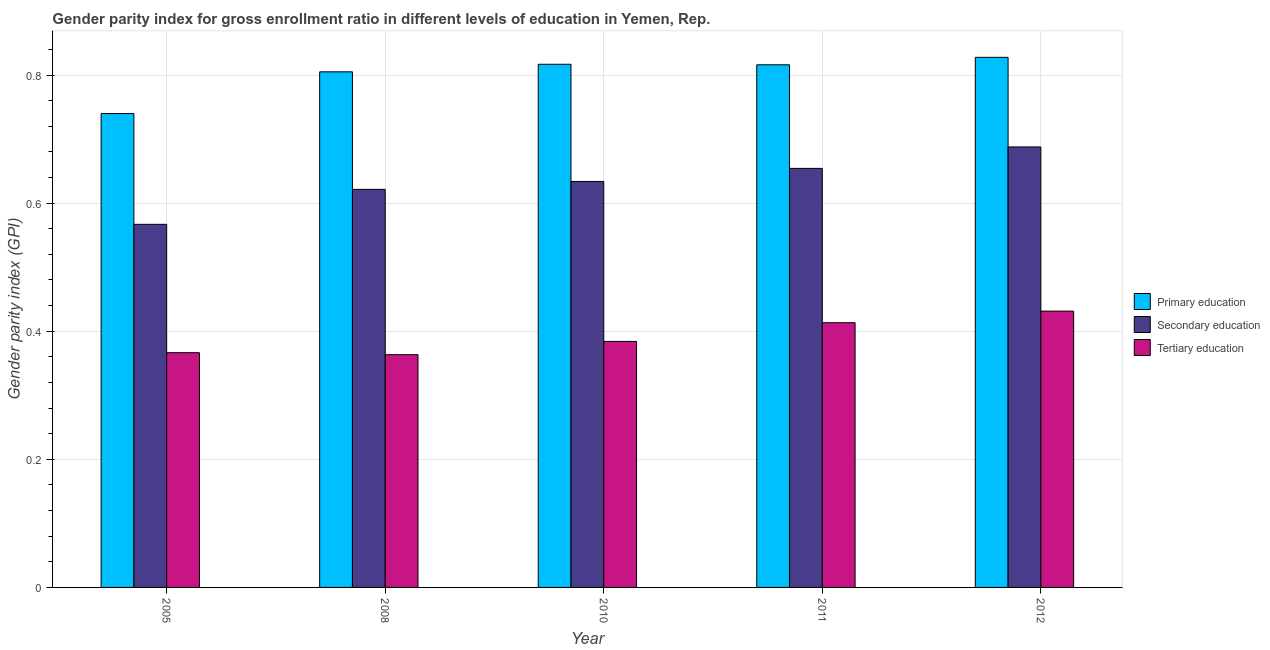Are the number of bars per tick equal to the number of legend labels?
Offer a terse response. Yes. Are the number of bars on each tick of the X-axis equal?
Your answer should be very brief. Yes. How many bars are there on the 4th tick from the left?
Your answer should be compact. 3. What is the gender parity index in primary education in 2012?
Give a very brief answer. 0.83. Across all years, what is the maximum gender parity index in tertiary education?
Ensure brevity in your answer.  0.43. Across all years, what is the minimum gender parity index in tertiary education?
Provide a short and direct response. 0.36. In which year was the gender parity index in secondary education minimum?
Keep it short and to the point. 2005. What is the total gender parity index in secondary education in the graph?
Provide a short and direct response. 3.16. What is the difference between the gender parity index in tertiary education in 2008 and that in 2012?
Keep it short and to the point. -0.07. What is the difference between the gender parity index in secondary education in 2010 and the gender parity index in tertiary education in 2008?
Your answer should be very brief. 0.01. What is the average gender parity index in tertiary education per year?
Make the answer very short. 0.39. In the year 2010, what is the difference between the gender parity index in primary education and gender parity index in secondary education?
Provide a succinct answer. 0. In how many years, is the gender parity index in secondary education greater than 0.68?
Offer a very short reply. 1. What is the ratio of the gender parity index in tertiary education in 2005 to that in 2008?
Ensure brevity in your answer.  1.01. Is the difference between the gender parity index in primary education in 2008 and 2010 greater than the difference between the gender parity index in tertiary education in 2008 and 2010?
Your answer should be compact. No. What is the difference between the highest and the second highest gender parity index in secondary education?
Your answer should be compact. 0.03. What is the difference between the highest and the lowest gender parity index in primary education?
Provide a short and direct response. 0.09. In how many years, is the gender parity index in secondary education greater than the average gender parity index in secondary education taken over all years?
Ensure brevity in your answer.  3. What does the 3rd bar from the left in 2008 represents?
Your answer should be very brief. Tertiary education. What does the 1st bar from the right in 2008 represents?
Your response must be concise. Tertiary education. Is it the case that in every year, the sum of the gender parity index in primary education and gender parity index in secondary education is greater than the gender parity index in tertiary education?
Your answer should be compact. Yes. How many bars are there?
Your answer should be compact. 15. Are all the bars in the graph horizontal?
Provide a succinct answer. No. Are the values on the major ticks of Y-axis written in scientific E-notation?
Your answer should be compact. No. Does the graph contain any zero values?
Your answer should be very brief. No. Does the graph contain grids?
Offer a very short reply. Yes. Where does the legend appear in the graph?
Ensure brevity in your answer.  Center right. How are the legend labels stacked?
Provide a succinct answer. Vertical. What is the title of the graph?
Your response must be concise. Gender parity index for gross enrollment ratio in different levels of education in Yemen, Rep. Does "Coal sources" appear as one of the legend labels in the graph?
Ensure brevity in your answer.  No. What is the label or title of the X-axis?
Offer a terse response. Year. What is the label or title of the Y-axis?
Your answer should be compact. Gender parity index (GPI). What is the Gender parity index (GPI) in Primary education in 2005?
Make the answer very short. 0.74. What is the Gender parity index (GPI) of Secondary education in 2005?
Provide a short and direct response. 0.57. What is the Gender parity index (GPI) of Tertiary education in 2005?
Provide a short and direct response. 0.37. What is the Gender parity index (GPI) of Primary education in 2008?
Your answer should be compact. 0.8. What is the Gender parity index (GPI) in Secondary education in 2008?
Make the answer very short. 0.62. What is the Gender parity index (GPI) in Tertiary education in 2008?
Your response must be concise. 0.36. What is the Gender parity index (GPI) of Primary education in 2010?
Your answer should be very brief. 0.82. What is the Gender parity index (GPI) in Secondary education in 2010?
Provide a succinct answer. 0.63. What is the Gender parity index (GPI) in Tertiary education in 2010?
Your answer should be very brief. 0.38. What is the Gender parity index (GPI) in Primary education in 2011?
Your answer should be compact. 0.82. What is the Gender parity index (GPI) of Secondary education in 2011?
Make the answer very short. 0.65. What is the Gender parity index (GPI) of Tertiary education in 2011?
Your answer should be very brief. 0.41. What is the Gender parity index (GPI) of Primary education in 2012?
Your answer should be compact. 0.83. What is the Gender parity index (GPI) in Secondary education in 2012?
Offer a terse response. 0.69. What is the Gender parity index (GPI) of Tertiary education in 2012?
Your answer should be compact. 0.43. Across all years, what is the maximum Gender parity index (GPI) in Primary education?
Your response must be concise. 0.83. Across all years, what is the maximum Gender parity index (GPI) in Secondary education?
Keep it short and to the point. 0.69. Across all years, what is the maximum Gender parity index (GPI) of Tertiary education?
Keep it short and to the point. 0.43. Across all years, what is the minimum Gender parity index (GPI) of Primary education?
Your response must be concise. 0.74. Across all years, what is the minimum Gender parity index (GPI) of Secondary education?
Provide a short and direct response. 0.57. Across all years, what is the minimum Gender parity index (GPI) in Tertiary education?
Your answer should be very brief. 0.36. What is the total Gender parity index (GPI) in Primary education in the graph?
Your answer should be compact. 4.01. What is the total Gender parity index (GPI) of Secondary education in the graph?
Provide a short and direct response. 3.16. What is the total Gender parity index (GPI) of Tertiary education in the graph?
Offer a terse response. 1.96. What is the difference between the Gender parity index (GPI) in Primary education in 2005 and that in 2008?
Your answer should be compact. -0.07. What is the difference between the Gender parity index (GPI) of Secondary education in 2005 and that in 2008?
Give a very brief answer. -0.05. What is the difference between the Gender parity index (GPI) of Tertiary education in 2005 and that in 2008?
Your answer should be very brief. 0. What is the difference between the Gender parity index (GPI) of Primary education in 2005 and that in 2010?
Offer a very short reply. -0.08. What is the difference between the Gender parity index (GPI) in Secondary education in 2005 and that in 2010?
Provide a short and direct response. -0.07. What is the difference between the Gender parity index (GPI) in Tertiary education in 2005 and that in 2010?
Offer a very short reply. -0.02. What is the difference between the Gender parity index (GPI) in Primary education in 2005 and that in 2011?
Provide a short and direct response. -0.08. What is the difference between the Gender parity index (GPI) in Secondary education in 2005 and that in 2011?
Your answer should be very brief. -0.09. What is the difference between the Gender parity index (GPI) in Tertiary education in 2005 and that in 2011?
Provide a short and direct response. -0.05. What is the difference between the Gender parity index (GPI) of Primary education in 2005 and that in 2012?
Provide a short and direct response. -0.09. What is the difference between the Gender parity index (GPI) of Secondary education in 2005 and that in 2012?
Offer a very short reply. -0.12. What is the difference between the Gender parity index (GPI) in Tertiary education in 2005 and that in 2012?
Ensure brevity in your answer.  -0.06. What is the difference between the Gender parity index (GPI) in Primary education in 2008 and that in 2010?
Ensure brevity in your answer.  -0.01. What is the difference between the Gender parity index (GPI) of Secondary education in 2008 and that in 2010?
Provide a succinct answer. -0.01. What is the difference between the Gender parity index (GPI) in Tertiary education in 2008 and that in 2010?
Your answer should be very brief. -0.02. What is the difference between the Gender parity index (GPI) in Primary education in 2008 and that in 2011?
Offer a very short reply. -0.01. What is the difference between the Gender parity index (GPI) in Secondary education in 2008 and that in 2011?
Provide a short and direct response. -0.03. What is the difference between the Gender parity index (GPI) in Tertiary education in 2008 and that in 2011?
Ensure brevity in your answer.  -0.05. What is the difference between the Gender parity index (GPI) in Primary education in 2008 and that in 2012?
Make the answer very short. -0.02. What is the difference between the Gender parity index (GPI) of Secondary education in 2008 and that in 2012?
Your answer should be compact. -0.07. What is the difference between the Gender parity index (GPI) in Tertiary education in 2008 and that in 2012?
Provide a succinct answer. -0.07. What is the difference between the Gender parity index (GPI) in Primary education in 2010 and that in 2011?
Keep it short and to the point. 0. What is the difference between the Gender parity index (GPI) of Secondary education in 2010 and that in 2011?
Offer a terse response. -0.02. What is the difference between the Gender parity index (GPI) in Tertiary education in 2010 and that in 2011?
Provide a short and direct response. -0.03. What is the difference between the Gender parity index (GPI) of Primary education in 2010 and that in 2012?
Offer a very short reply. -0.01. What is the difference between the Gender parity index (GPI) in Secondary education in 2010 and that in 2012?
Provide a succinct answer. -0.05. What is the difference between the Gender parity index (GPI) in Tertiary education in 2010 and that in 2012?
Offer a very short reply. -0.05. What is the difference between the Gender parity index (GPI) of Primary education in 2011 and that in 2012?
Offer a terse response. -0.01. What is the difference between the Gender parity index (GPI) of Secondary education in 2011 and that in 2012?
Give a very brief answer. -0.03. What is the difference between the Gender parity index (GPI) in Tertiary education in 2011 and that in 2012?
Your answer should be compact. -0.02. What is the difference between the Gender parity index (GPI) in Primary education in 2005 and the Gender parity index (GPI) in Secondary education in 2008?
Provide a succinct answer. 0.12. What is the difference between the Gender parity index (GPI) of Primary education in 2005 and the Gender parity index (GPI) of Tertiary education in 2008?
Offer a very short reply. 0.38. What is the difference between the Gender parity index (GPI) of Secondary education in 2005 and the Gender parity index (GPI) of Tertiary education in 2008?
Your answer should be compact. 0.2. What is the difference between the Gender parity index (GPI) of Primary education in 2005 and the Gender parity index (GPI) of Secondary education in 2010?
Offer a terse response. 0.11. What is the difference between the Gender parity index (GPI) of Primary education in 2005 and the Gender parity index (GPI) of Tertiary education in 2010?
Offer a very short reply. 0.36. What is the difference between the Gender parity index (GPI) of Secondary education in 2005 and the Gender parity index (GPI) of Tertiary education in 2010?
Ensure brevity in your answer.  0.18. What is the difference between the Gender parity index (GPI) of Primary education in 2005 and the Gender parity index (GPI) of Secondary education in 2011?
Give a very brief answer. 0.09. What is the difference between the Gender parity index (GPI) in Primary education in 2005 and the Gender parity index (GPI) in Tertiary education in 2011?
Offer a very short reply. 0.33. What is the difference between the Gender parity index (GPI) of Secondary education in 2005 and the Gender parity index (GPI) of Tertiary education in 2011?
Keep it short and to the point. 0.15. What is the difference between the Gender parity index (GPI) in Primary education in 2005 and the Gender parity index (GPI) in Secondary education in 2012?
Your answer should be very brief. 0.05. What is the difference between the Gender parity index (GPI) of Primary education in 2005 and the Gender parity index (GPI) of Tertiary education in 2012?
Your answer should be very brief. 0.31. What is the difference between the Gender parity index (GPI) of Secondary education in 2005 and the Gender parity index (GPI) of Tertiary education in 2012?
Ensure brevity in your answer.  0.14. What is the difference between the Gender parity index (GPI) in Primary education in 2008 and the Gender parity index (GPI) in Secondary education in 2010?
Your response must be concise. 0.17. What is the difference between the Gender parity index (GPI) of Primary education in 2008 and the Gender parity index (GPI) of Tertiary education in 2010?
Provide a short and direct response. 0.42. What is the difference between the Gender parity index (GPI) of Secondary education in 2008 and the Gender parity index (GPI) of Tertiary education in 2010?
Ensure brevity in your answer.  0.24. What is the difference between the Gender parity index (GPI) of Primary education in 2008 and the Gender parity index (GPI) of Secondary education in 2011?
Keep it short and to the point. 0.15. What is the difference between the Gender parity index (GPI) of Primary education in 2008 and the Gender parity index (GPI) of Tertiary education in 2011?
Give a very brief answer. 0.39. What is the difference between the Gender parity index (GPI) of Secondary education in 2008 and the Gender parity index (GPI) of Tertiary education in 2011?
Provide a succinct answer. 0.21. What is the difference between the Gender parity index (GPI) in Primary education in 2008 and the Gender parity index (GPI) in Secondary education in 2012?
Offer a very short reply. 0.12. What is the difference between the Gender parity index (GPI) of Primary education in 2008 and the Gender parity index (GPI) of Tertiary education in 2012?
Your answer should be very brief. 0.37. What is the difference between the Gender parity index (GPI) in Secondary education in 2008 and the Gender parity index (GPI) in Tertiary education in 2012?
Your answer should be compact. 0.19. What is the difference between the Gender parity index (GPI) in Primary education in 2010 and the Gender parity index (GPI) in Secondary education in 2011?
Your answer should be compact. 0.16. What is the difference between the Gender parity index (GPI) in Primary education in 2010 and the Gender parity index (GPI) in Tertiary education in 2011?
Provide a succinct answer. 0.4. What is the difference between the Gender parity index (GPI) of Secondary education in 2010 and the Gender parity index (GPI) of Tertiary education in 2011?
Your answer should be compact. 0.22. What is the difference between the Gender parity index (GPI) of Primary education in 2010 and the Gender parity index (GPI) of Secondary education in 2012?
Your answer should be very brief. 0.13. What is the difference between the Gender parity index (GPI) in Primary education in 2010 and the Gender parity index (GPI) in Tertiary education in 2012?
Your answer should be very brief. 0.39. What is the difference between the Gender parity index (GPI) of Secondary education in 2010 and the Gender parity index (GPI) of Tertiary education in 2012?
Your answer should be very brief. 0.2. What is the difference between the Gender parity index (GPI) of Primary education in 2011 and the Gender parity index (GPI) of Secondary education in 2012?
Give a very brief answer. 0.13. What is the difference between the Gender parity index (GPI) in Primary education in 2011 and the Gender parity index (GPI) in Tertiary education in 2012?
Ensure brevity in your answer.  0.38. What is the difference between the Gender parity index (GPI) of Secondary education in 2011 and the Gender parity index (GPI) of Tertiary education in 2012?
Ensure brevity in your answer.  0.22. What is the average Gender parity index (GPI) in Primary education per year?
Give a very brief answer. 0.8. What is the average Gender parity index (GPI) of Secondary education per year?
Offer a terse response. 0.63. What is the average Gender parity index (GPI) in Tertiary education per year?
Provide a short and direct response. 0.39. In the year 2005, what is the difference between the Gender parity index (GPI) of Primary education and Gender parity index (GPI) of Secondary education?
Ensure brevity in your answer.  0.17. In the year 2005, what is the difference between the Gender parity index (GPI) in Primary education and Gender parity index (GPI) in Tertiary education?
Offer a very short reply. 0.37. In the year 2005, what is the difference between the Gender parity index (GPI) in Secondary education and Gender parity index (GPI) in Tertiary education?
Provide a short and direct response. 0.2. In the year 2008, what is the difference between the Gender parity index (GPI) of Primary education and Gender parity index (GPI) of Secondary education?
Give a very brief answer. 0.18. In the year 2008, what is the difference between the Gender parity index (GPI) in Primary education and Gender parity index (GPI) in Tertiary education?
Ensure brevity in your answer.  0.44. In the year 2008, what is the difference between the Gender parity index (GPI) in Secondary education and Gender parity index (GPI) in Tertiary education?
Provide a succinct answer. 0.26. In the year 2010, what is the difference between the Gender parity index (GPI) of Primary education and Gender parity index (GPI) of Secondary education?
Provide a succinct answer. 0.18. In the year 2010, what is the difference between the Gender parity index (GPI) in Primary education and Gender parity index (GPI) in Tertiary education?
Keep it short and to the point. 0.43. In the year 2010, what is the difference between the Gender parity index (GPI) of Secondary education and Gender parity index (GPI) of Tertiary education?
Your answer should be very brief. 0.25. In the year 2011, what is the difference between the Gender parity index (GPI) in Primary education and Gender parity index (GPI) in Secondary education?
Keep it short and to the point. 0.16. In the year 2011, what is the difference between the Gender parity index (GPI) of Primary education and Gender parity index (GPI) of Tertiary education?
Ensure brevity in your answer.  0.4. In the year 2011, what is the difference between the Gender parity index (GPI) of Secondary education and Gender parity index (GPI) of Tertiary education?
Your answer should be very brief. 0.24. In the year 2012, what is the difference between the Gender parity index (GPI) in Primary education and Gender parity index (GPI) in Secondary education?
Ensure brevity in your answer.  0.14. In the year 2012, what is the difference between the Gender parity index (GPI) in Primary education and Gender parity index (GPI) in Tertiary education?
Ensure brevity in your answer.  0.4. In the year 2012, what is the difference between the Gender parity index (GPI) in Secondary education and Gender parity index (GPI) in Tertiary education?
Provide a succinct answer. 0.26. What is the ratio of the Gender parity index (GPI) in Primary education in 2005 to that in 2008?
Your response must be concise. 0.92. What is the ratio of the Gender parity index (GPI) in Secondary education in 2005 to that in 2008?
Make the answer very short. 0.91. What is the ratio of the Gender parity index (GPI) of Tertiary education in 2005 to that in 2008?
Keep it short and to the point. 1.01. What is the ratio of the Gender parity index (GPI) of Primary education in 2005 to that in 2010?
Ensure brevity in your answer.  0.91. What is the ratio of the Gender parity index (GPI) of Secondary education in 2005 to that in 2010?
Offer a terse response. 0.89. What is the ratio of the Gender parity index (GPI) of Tertiary education in 2005 to that in 2010?
Your response must be concise. 0.95. What is the ratio of the Gender parity index (GPI) in Primary education in 2005 to that in 2011?
Offer a terse response. 0.91. What is the ratio of the Gender parity index (GPI) of Secondary education in 2005 to that in 2011?
Your answer should be very brief. 0.87. What is the ratio of the Gender parity index (GPI) of Tertiary education in 2005 to that in 2011?
Give a very brief answer. 0.89. What is the ratio of the Gender parity index (GPI) in Primary education in 2005 to that in 2012?
Ensure brevity in your answer.  0.89. What is the ratio of the Gender parity index (GPI) of Secondary education in 2005 to that in 2012?
Ensure brevity in your answer.  0.82. What is the ratio of the Gender parity index (GPI) of Tertiary education in 2005 to that in 2012?
Your response must be concise. 0.85. What is the ratio of the Gender parity index (GPI) in Primary education in 2008 to that in 2010?
Provide a succinct answer. 0.99. What is the ratio of the Gender parity index (GPI) of Secondary education in 2008 to that in 2010?
Provide a short and direct response. 0.98. What is the ratio of the Gender parity index (GPI) in Tertiary education in 2008 to that in 2010?
Give a very brief answer. 0.95. What is the ratio of the Gender parity index (GPI) of Primary education in 2008 to that in 2011?
Provide a succinct answer. 0.99. What is the ratio of the Gender parity index (GPI) of Secondary education in 2008 to that in 2011?
Give a very brief answer. 0.95. What is the ratio of the Gender parity index (GPI) in Tertiary education in 2008 to that in 2011?
Offer a very short reply. 0.88. What is the ratio of the Gender parity index (GPI) in Primary education in 2008 to that in 2012?
Ensure brevity in your answer.  0.97. What is the ratio of the Gender parity index (GPI) in Secondary education in 2008 to that in 2012?
Your answer should be compact. 0.9. What is the ratio of the Gender parity index (GPI) of Tertiary education in 2008 to that in 2012?
Give a very brief answer. 0.84. What is the ratio of the Gender parity index (GPI) of Secondary education in 2010 to that in 2011?
Provide a short and direct response. 0.97. What is the ratio of the Gender parity index (GPI) of Tertiary education in 2010 to that in 2011?
Your answer should be very brief. 0.93. What is the ratio of the Gender parity index (GPI) of Primary education in 2010 to that in 2012?
Your answer should be very brief. 0.99. What is the ratio of the Gender parity index (GPI) of Secondary education in 2010 to that in 2012?
Your response must be concise. 0.92. What is the ratio of the Gender parity index (GPI) in Tertiary education in 2010 to that in 2012?
Provide a succinct answer. 0.89. What is the ratio of the Gender parity index (GPI) in Primary education in 2011 to that in 2012?
Provide a short and direct response. 0.99. What is the ratio of the Gender parity index (GPI) of Secondary education in 2011 to that in 2012?
Provide a succinct answer. 0.95. What is the ratio of the Gender parity index (GPI) of Tertiary education in 2011 to that in 2012?
Your answer should be compact. 0.96. What is the difference between the highest and the second highest Gender parity index (GPI) in Primary education?
Give a very brief answer. 0.01. What is the difference between the highest and the second highest Gender parity index (GPI) in Secondary education?
Make the answer very short. 0.03. What is the difference between the highest and the second highest Gender parity index (GPI) of Tertiary education?
Provide a succinct answer. 0.02. What is the difference between the highest and the lowest Gender parity index (GPI) in Primary education?
Make the answer very short. 0.09. What is the difference between the highest and the lowest Gender parity index (GPI) of Secondary education?
Your response must be concise. 0.12. What is the difference between the highest and the lowest Gender parity index (GPI) in Tertiary education?
Ensure brevity in your answer.  0.07. 